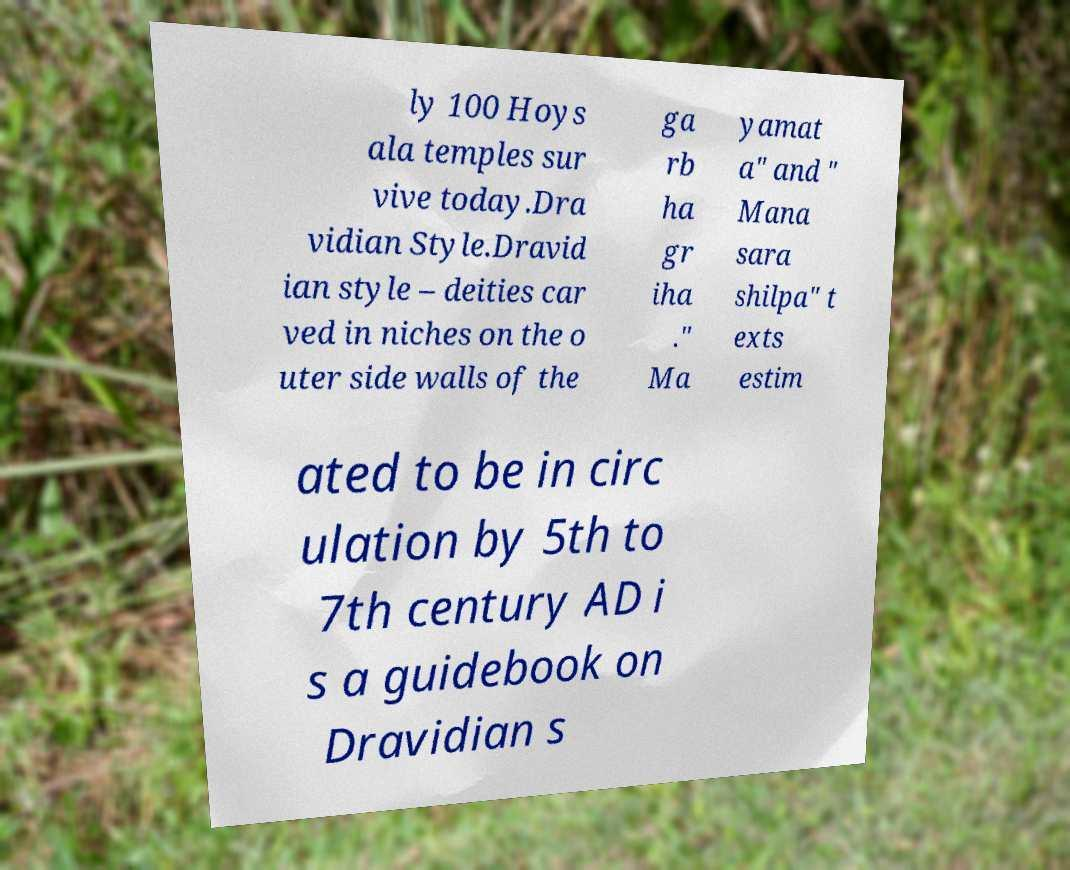For documentation purposes, I need the text within this image transcribed. Could you provide that? ly 100 Hoys ala temples sur vive today.Dra vidian Style.Dravid ian style – deities car ved in niches on the o uter side walls of the ga rb ha gr iha ." Ma yamat a" and " Mana sara shilpa" t exts estim ated to be in circ ulation by 5th to 7th century AD i s a guidebook on Dravidian s 